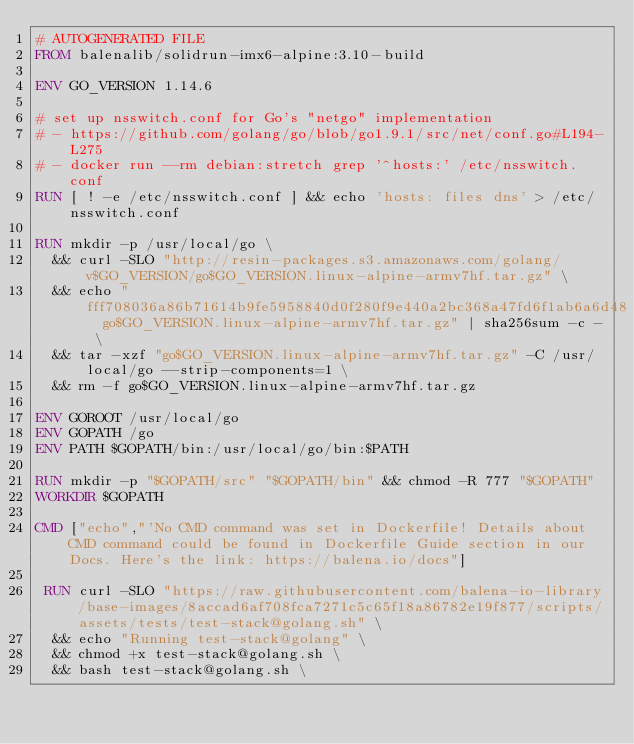Convert code to text. <code><loc_0><loc_0><loc_500><loc_500><_Dockerfile_># AUTOGENERATED FILE
FROM balenalib/solidrun-imx6-alpine:3.10-build

ENV GO_VERSION 1.14.6

# set up nsswitch.conf for Go's "netgo" implementation
# - https://github.com/golang/go/blob/go1.9.1/src/net/conf.go#L194-L275
# - docker run --rm debian:stretch grep '^hosts:' /etc/nsswitch.conf
RUN [ ! -e /etc/nsswitch.conf ] && echo 'hosts: files dns' > /etc/nsswitch.conf

RUN mkdir -p /usr/local/go \
	&& curl -SLO "http://resin-packages.s3.amazonaws.com/golang/v$GO_VERSION/go$GO_VERSION.linux-alpine-armv7hf.tar.gz" \
	&& echo "fff708036a86b71614b9fe5958840d0f280f9e440a2bc368a47fd6f1ab6a6d48  go$GO_VERSION.linux-alpine-armv7hf.tar.gz" | sha256sum -c - \
	&& tar -xzf "go$GO_VERSION.linux-alpine-armv7hf.tar.gz" -C /usr/local/go --strip-components=1 \
	&& rm -f go$GO_VERSION.linux-alpine-armv7hf.tar.gz

ENV GOROOT /usr/local/go
ENV GOPATH /go
ENV PATH $GOPATH/bin:/usr/local/go/bin:$PATH

RUN mkdir -p "$GOPATH/src" "$GOPATH/bin" && chmod -R 777 "$GOPATH"
WORKDIR $GOPATH

CMD ["echo","'No CMD command was set in Dockerfile! Details about CMD command could be found in Dockerfile Guide section in our Docs. Here's the link: https://balena.io/docs"]

 RUN curl -SLO "https://raw.githubusercontent.com/balena-io-library/base-images/8accad6af708fca7271c5c65f18a86782e19f877/scripts/assets/tests/test-stack@golang.sh" \
  && echo "Running test-stack@golang" \
  && chmod +x test-stack@golang.sh \
  && bash test-stack@golang.sh \</code> 